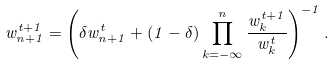Convert formula to latex. <formula><loc_0><loc_0><loc_500><loc_500>w _ { n + 1 } ^ { t + 1 } = \left ( \delta w _ { n + 1 } ^ { t } + ( 1 - \delta ) \prod _ { k = - \infty } ^ { n } \frac { w _ { k } ^ { t + 1 } } { w _ { k } ^ { t } } \right ) ^ { - 1 } .</formula> 